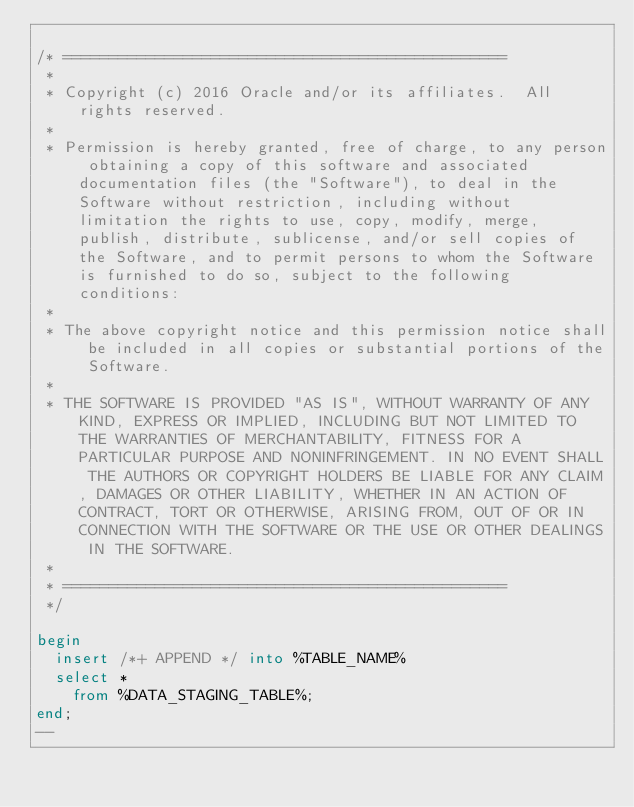Convert code to text. <code><loc_0><loc_0><loc_500><loc_500><_SQL_>
/* ================================================  
 *    
 * Copyright (c) 2016 Oracle and/or its affiliates.  All rights reserved.
 *
 * Permission is hereby granted, free of charge, to any person obtaining a copy of this software and associated documentation files (the "Software"), to deal in the Software without restriction, including without limitation the rights to use, copy, modify, merge, publish, distribute, sublicense, and/or sell copies of the Software, and to permit persons to whom the Software is furnished to do so, subject to the following conditions:
 *
 * The above copyright notice and this permission notice shall be included in all copies or substantial portions of the Software.
 *
 * THE SOFTWARE IS PROVIDED "AS IS", WITHOUT WARRANTY OF ANY KIND, EXPRESS OR IMPLIED, INCLUDING BUT NOT LIMITED TO THE WARRANTIES OF MERCHANTABILITY, FITNESS FOR A PARTICULAR PURPOSE AND NONINFRINGEMENT. IN NO EVENT SHALL THE AUTHORS OR COPYRIGHT HOLDERS BE LIABLE FOR ANY CLAIM, DAMAGES OR OTHER LIABILITY, WHETHER IN AN ACTION OF CONTRACT, TORT OR OTHERWISE, ARISING FROM, OUT OF OR IN CONNECTION WITH THE SOFTWARE OR THE USE OR OTHER DEALINGS IN THE SOFTWARE.
 *
 * ================================================ 
 */

begin
  insert /*+ APPEND */ into %TABLE_NAME%
  select *
    from %DATA_STAGING_TABLE%;
end;
--</code> 